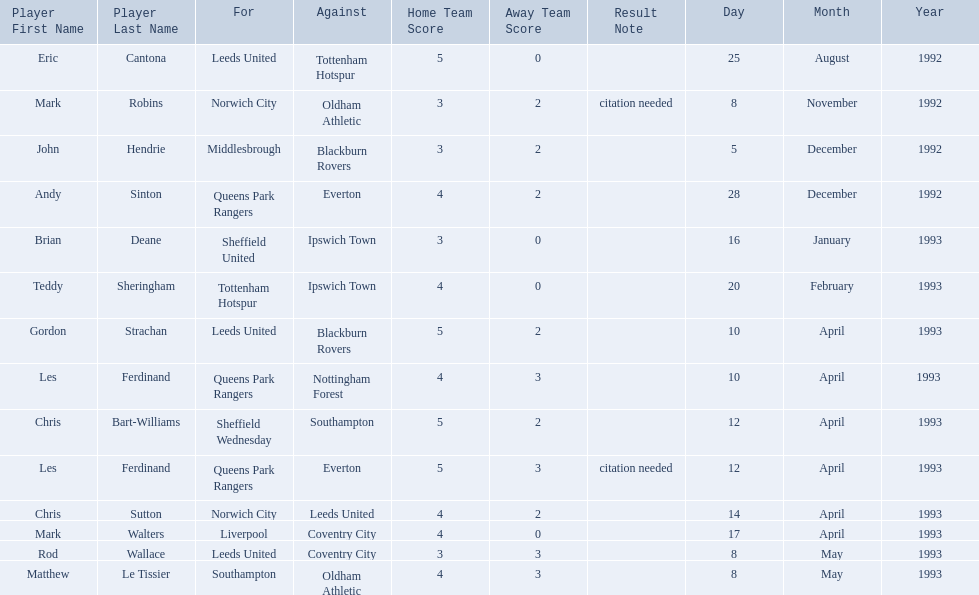What are the results? 5–0, 3–2[citation needed], 3–2, 4–2, 3–0, 4–0, 5–2, 4–3, 5–2, 5–3[citation needed], 4–2, 4–0, 3–3, 4–3. What result did mark robins have? 3–2[citation needed]. What other player had that result? John Hendrie. 